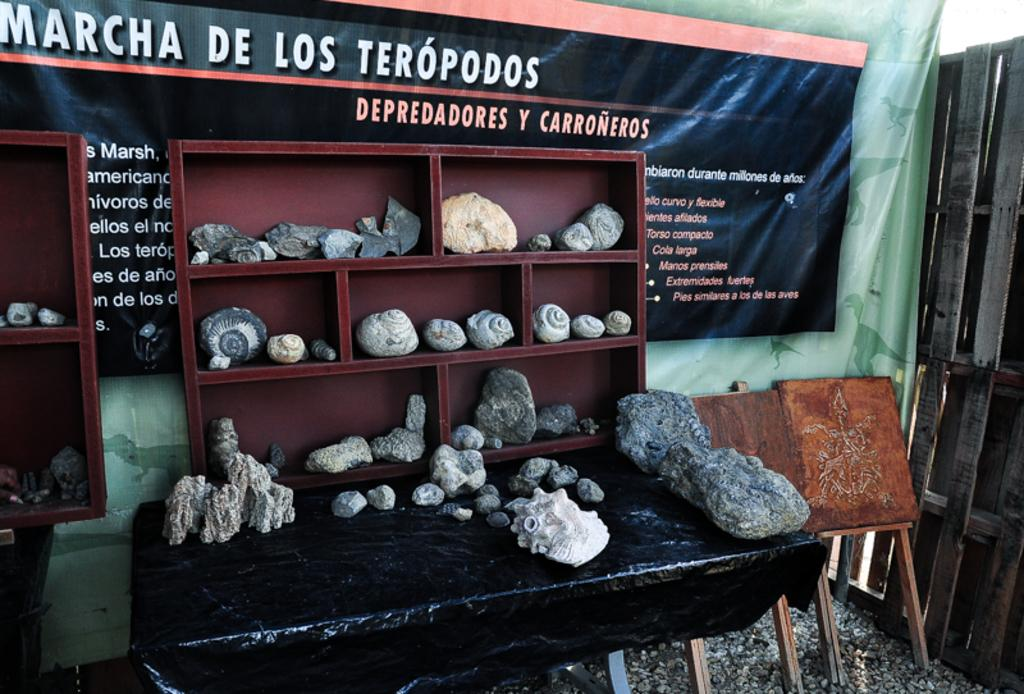What type of objects can be seen on the table in the image? There are stones and sea shells placed on a table in the image. Where else can the stones and sea shells be found in the image? The stones and sea shells are also placed on a display cupboard. What is visible behind the display cupboard in the image? There is a banner visible behind the display cupboard. What type of religious symbol can be seen on the stones in the image? There is no religious symbol present on the stones in the image. How many ladybugs are crawling on the sea shells in the image? There are no ladybugs present on the sea shells in the image. 